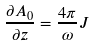<formula> <loc_0><loc_0><loc_500><loc_500>\frac { \partial A _ { 0 } } { \partial z } = \frac { 4 \pi } \omega J</formula> 